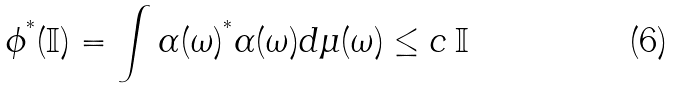<formula> <loc_0><loc_0><loc_500><loc_500>\phi ^ { ^ { * } } ( \mathbb { I } ) = \int \alpha ( \omega ) ^ { ^ { * } } \alpha ( \omega ) d \mu ( \omega ) \leq c \, \mathbb { I }</formula> 